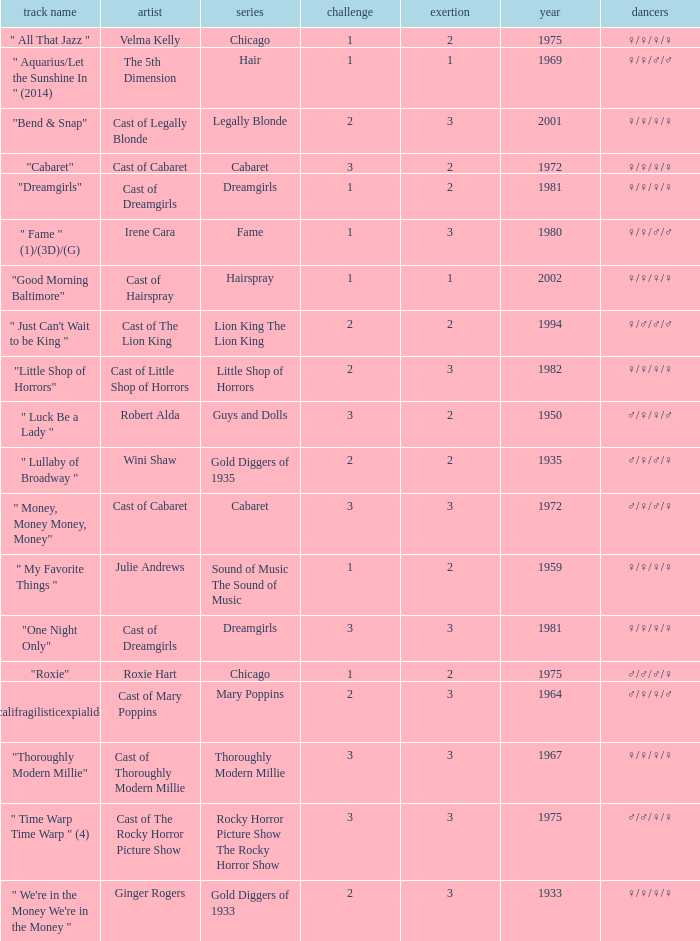How many shows were in 1994? 1.0. 